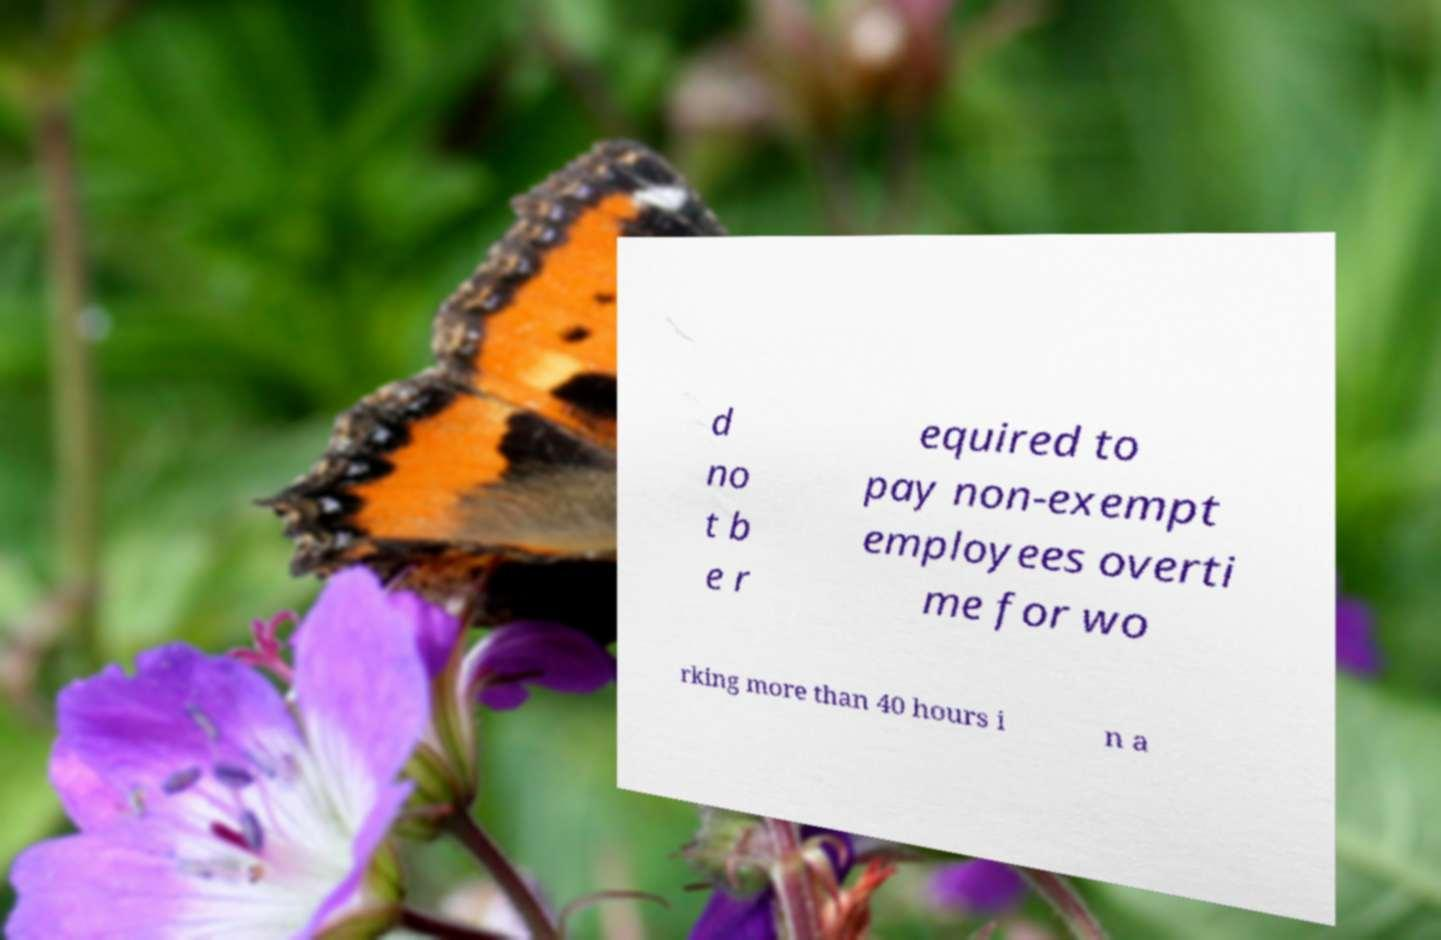What messages or text are displayed in this image? I need them in a readable, typed format. d no t b e r equired to pay non-exempt employees overti me for wo rking more than 40 hours i n a 